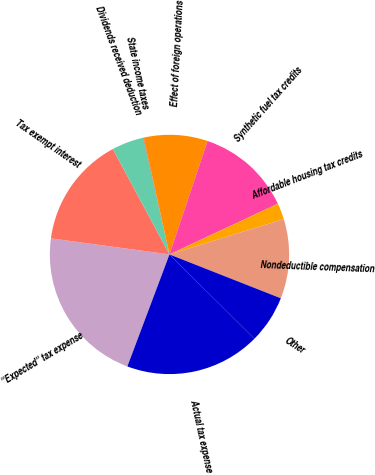<chart> <loc_0><loc_0><loc_500><loc_500><pie_chart><fcel>''Expected'' tax expense<fcel>Tax exempt interest<fcel>Dividends received deduction<fcel>State income taxes<fcel>Effect of foreign operations<fcel>Synthetic fuel tax credits<fcel>Affordable housing tax credits<fcel>Nondeductible compensation<fcel>Other<fcel>Actual tax expense<nl><fcel>21.42%<fcel>15.01%<fcel>4.33%<fcel>0.06%<fcel>8.61%<fcel>12.88%<fcel>2.2%<fcel>10.74%<fcel>6.47%<fcel>18.28%<nl></chart> 